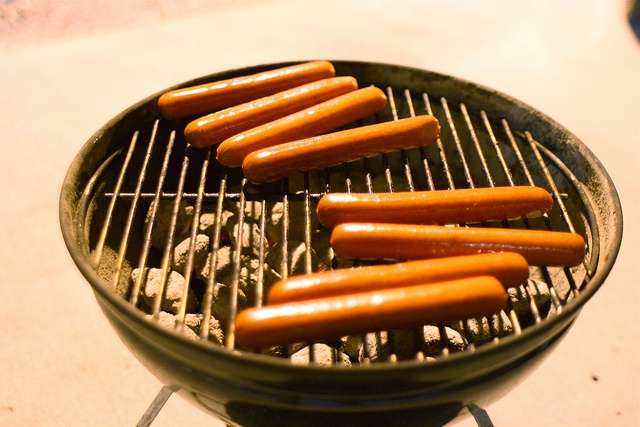Describe the objects in this image and their specific colors. I can see hot dog in pink, maroon, orange, and red tones, hot dog in pink, maroon, orange, and red tones, hot dog in pink, orange, red, and brown tones, hot dog in pink, maroon, orange, and red tones, and hot dog in pink, maroon, orange, and red tones in this image. 